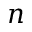Convert formula to latex. <formula><loc_0><loc_0><loc_500><loc_500>n</formula> 